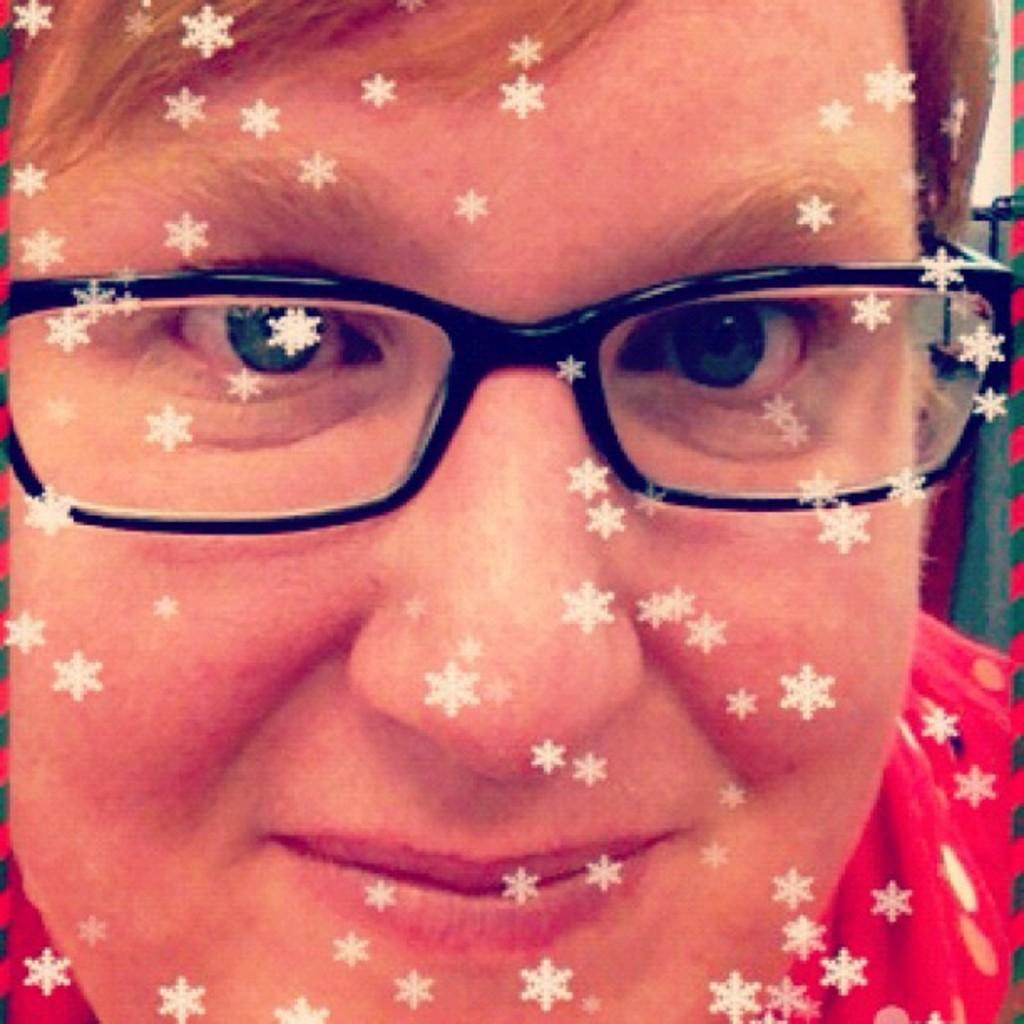What is the main subject of the image? There is a person in the image. What is the person wearing? The person is wearing a red dress and black frame spectacles. What is the person's facial expression? The person is smiling. What decorative elements are on the person's face? There are white color stars on the person's face. What type of art can be seen on the person's wrist in the image? There is no art visible on the person's wrist in the image. How does the person manage their time while wearing the watch in the image? There is no watch present in the image, so time management cannot be discussed. 